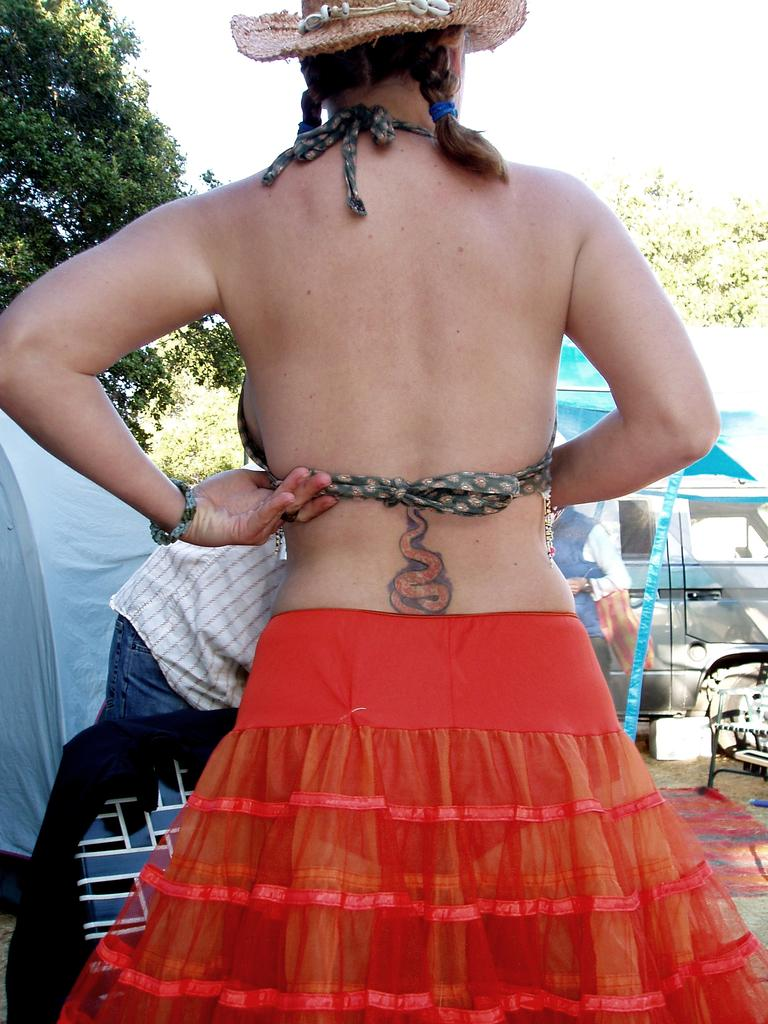What types of people are present in the image? There are women and men in the image. What can be seen on the ground in the image? There are motor vehicles on the ground in the image. What type of natural vegetation is present in the image? There are trees in the image. What is visible in the background of the image? The sky is visible in the image. How many clocks are hanging from the trees in the image? There are no clocks hanging from the trees in the image. What type of knot is being used to secure the motor vehicles in the image? There is no knot visible in the image, as the motor vehicles are not tied or secured in any way. 